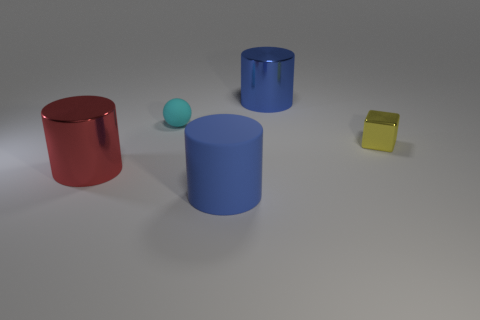Add 1 big metal things. How many objects exist? 6 Subtract all big metallic cylinders. How many cylinders are left? 1 Subtract all green cubes. How many blue cylinders are left? 2 Subtract all red cylinders. How many cylinders are left? 2 Subtract all large cyan blocks. Subtract all big rubber objects. How many objects are left? 4 Add 5 small cyan matte things. How many small cyan matte things are left? 6 Add 2 large matte balls. How many large matte balls exist? 2 Subtract 0 green spheres. How many objects are left? 5 Subtract all balls. How many objects are left? 4 Subtract 1 spheres. How many spheres are left? 0 